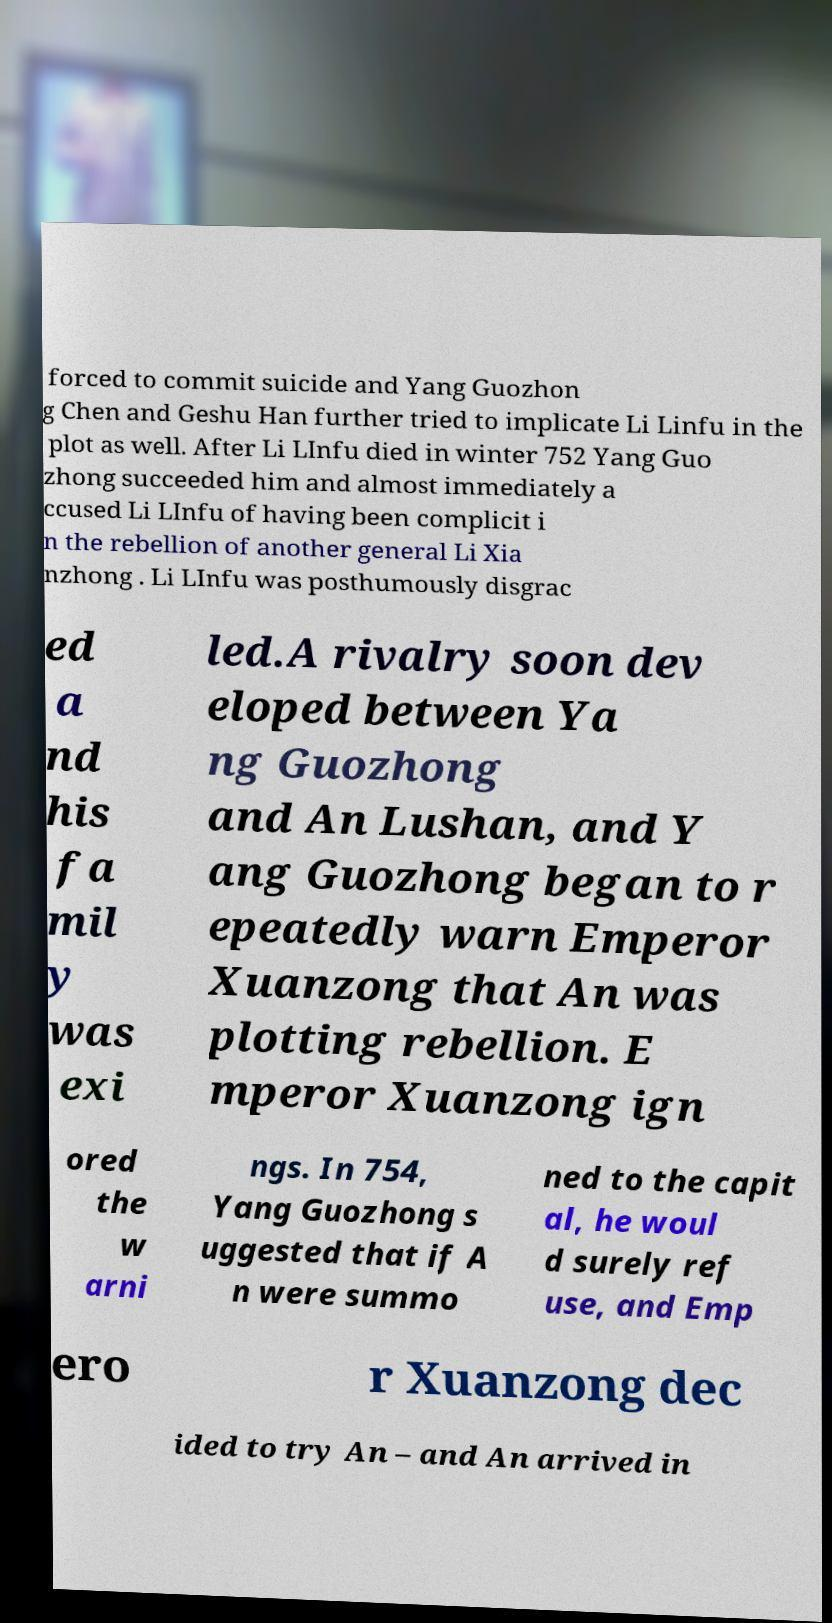Can you read and provide the text displayed in the image?This photo seems to have some interesting text. Can you extract and type it out for me? forced to commit suicide and Yang Guozhon g Chen and Geshu Han further tried to implicate Li Linfu in the plot as well. After Li LInfu died in winter 752 Yang Guo zhong succeeded him and almost immediately a ccused Li LInfu of having been complicit i n the rebellion of another general Li Xia nzhong . Li LInfu was posthumously disgrac ed a nd his fa mil y was exi led.A rivalry soon dev eloped between Ya ng Guozhong and An Lushan, and Y ang Guozhong began to r epeatedly warn Emperor Xuanzong that An was plotting rebellion. E mperor Xuanzong ign ored the w arni ngs. In 754, Yang Guozhong s uggested that if A n were summo ned to the capit al, he woul d surely ref use, and Emp ero r Xuanzong dec ided to try An – and An arrived in 